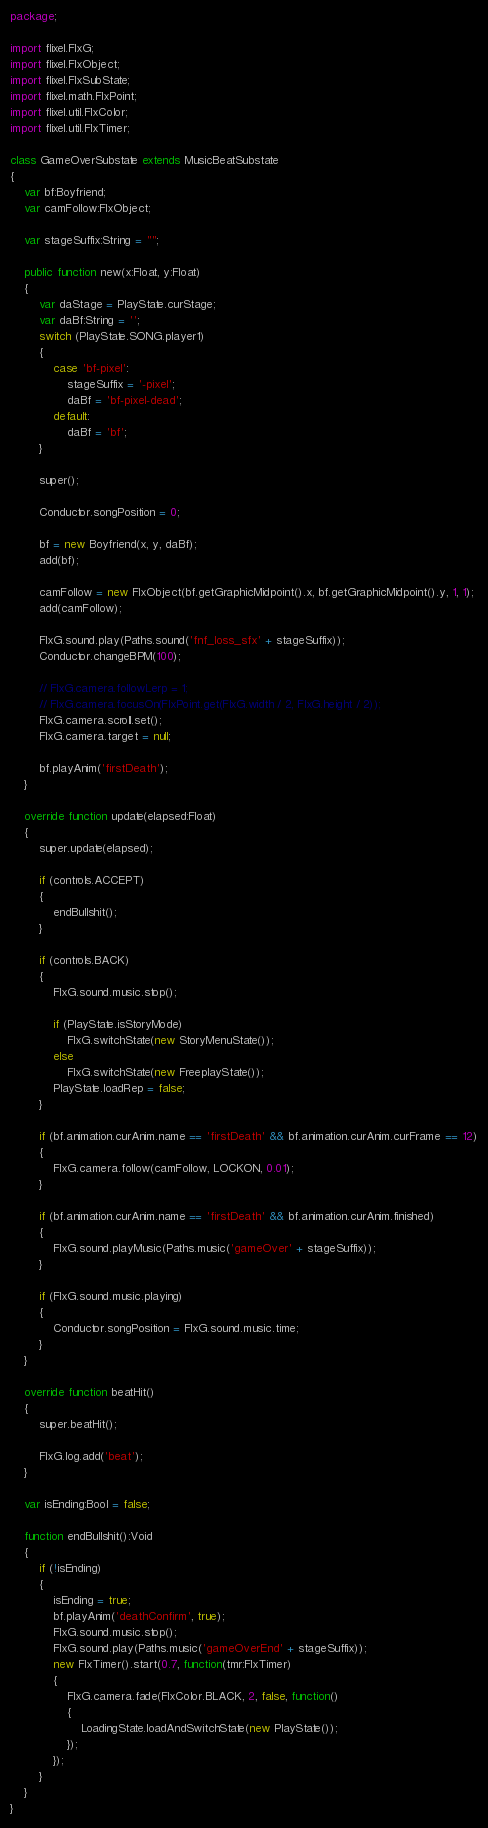<code> <loc_0><loc_0><loc_500><loc_500><_Haxe_>package;

import flixel.FlxG;
import flixel.FlxObject;
import flixel.FlxSubState;
import flixel.math.FlxPoint;
import flixel.util.FlxColor;
import flixel.util.FlxTimer;

class GameOverSubstate extends MusicBeatSubstate
{
	var bf:Boyfriend;
	var camFollow:FlxObject;

	var stageSuffix:String = "";

	public function new(x:Float, y:Float)
	{
		var daStage = PlayState.curStage;
		var daBf:String = '';
		switch (PlayState.SONG.player1)
		{
			case 'bf-pixel':
				stageSuffix = '-pixel';
				daBf = 'bf-pixel-dead';
			default:
				daBf = 'bf';
		}

		super();

		Conductor.songPosition = 0;

		bf = new Boyfriend(x, y, daBf);
		add(bf);

		camFollow = new FlxObject(bf.getGraphicMidpoint().x, bf.getGraphicMidpoint().y, 1, 1);
		add(camFollow);

		FlxG.sound.play(Paths.sound('fnf_loss_sfx' + stageSuffix));
		Conductor.changeBPM(100);

		// FlxG.camera.followLerp = 1;
		// FlxG.camera.focusOn(FlxPoint.get(FlxG.width / 2, FlxG.height / 2));
		FlxG.camera.scroll.set();
		FlxG.camera.target = null;

		bf.playAnim('firstDeath');
	}

	override function update(elapsed:Float)
	{
		super.update(elapsed);

		if (controls.ACCEPT)
		{
			endBullshit();
		}

		if (controls.BACK)
		{
			FlxG.sound.music.stop();

			if (PlayState.isStoryMode)
				FlxG.switchState(new StoryMenuState());
			else
				FlxG.switchState(new FreeplayState());
			PlayState.loadRep = false;
		}

		if (bf.animation.curAnim.name == 'firstDeath' && bf.animation.curAnim.curFrame == 12)
		{
			FlxG.camera.follow(camFollow, LOCKON, 0.01);
		}

		if (bf.animation.curAnim.name == 'firstDeath' && bf.animation.curAnim.finished)
		{
			FlxG.sound.playMusic(Paths.music('gameOver' + stageSuffix));
		}

		if (FlxG.sound.music.playing)
		{
			Conductor.songPosition = FlxG.sound.music.time;
		}
	}

	override function beatHit()
	{
		super.beatHit();

		FlxG.log.add('beat');
	}

	var isEnding:Bool = false;

	function endBullshit():Void
	{
		if (!isEnding)
		{
			isEnding = true;
			bf.playAnim('deathConfirm', true);
			FlxG.sound.music.stop();
			FlxG.sound.play(Paths.music('gameOverEnd' + stageSuffix));
			new FlxTimer().start(0.7, function(tmr:FlxTimer)
			{
				FlxG.camera.fade(FlxColor.BLACK, 2, false, function()
				{
					LoadingState.loadAndSwitchState(new PlayState());
				});
			});
		}
	}
}
</code> 